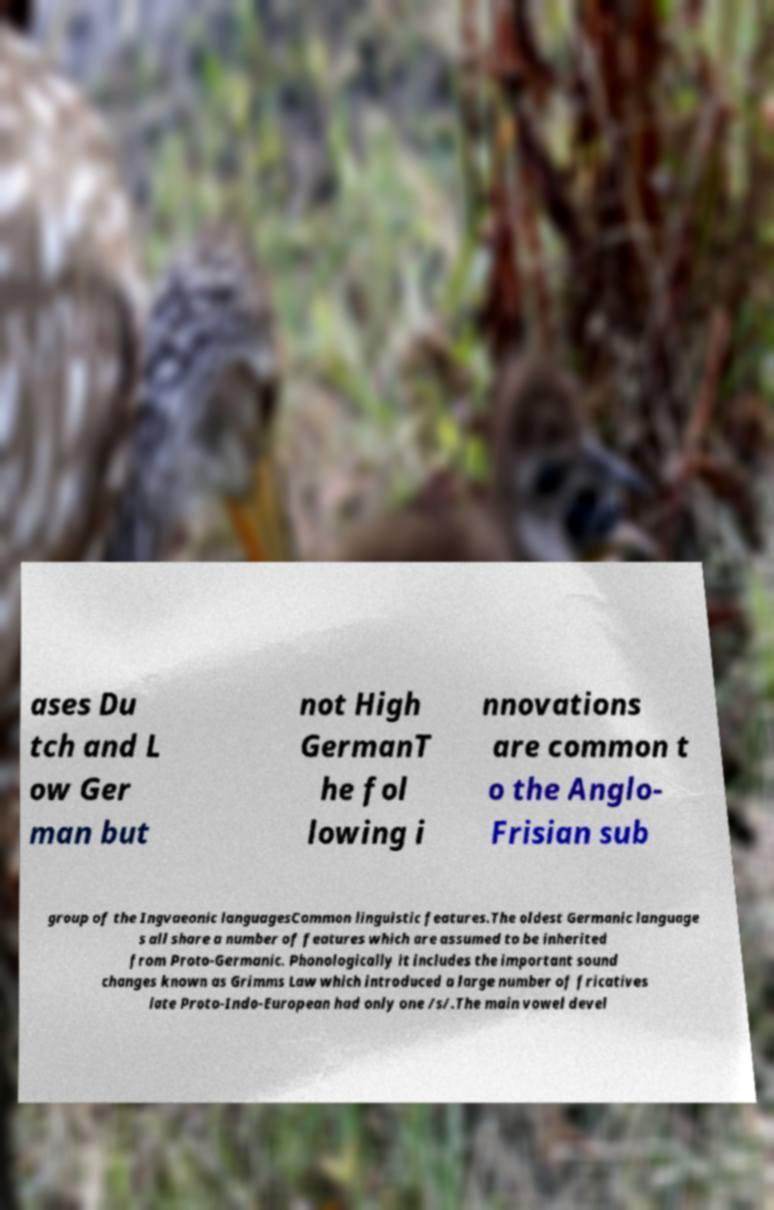Could you assist in decoding the text presented in this image and type it out clearly? ases Du tch and L ow Ger man but not High GermanT he fol lowing i nnovations are common t o the Anglo- Frisian sub group of the Ingvaeonic languagesCommon linguistic features.The oldest Germanic language s all share a number of features which are assumed to be inherited from Proto-Germanic. Phonologically it includes the important sound changes known as Grimms Law which introduced a large number of fricatives late Proto-Indo-European had only one /s/.The main vowel devel 